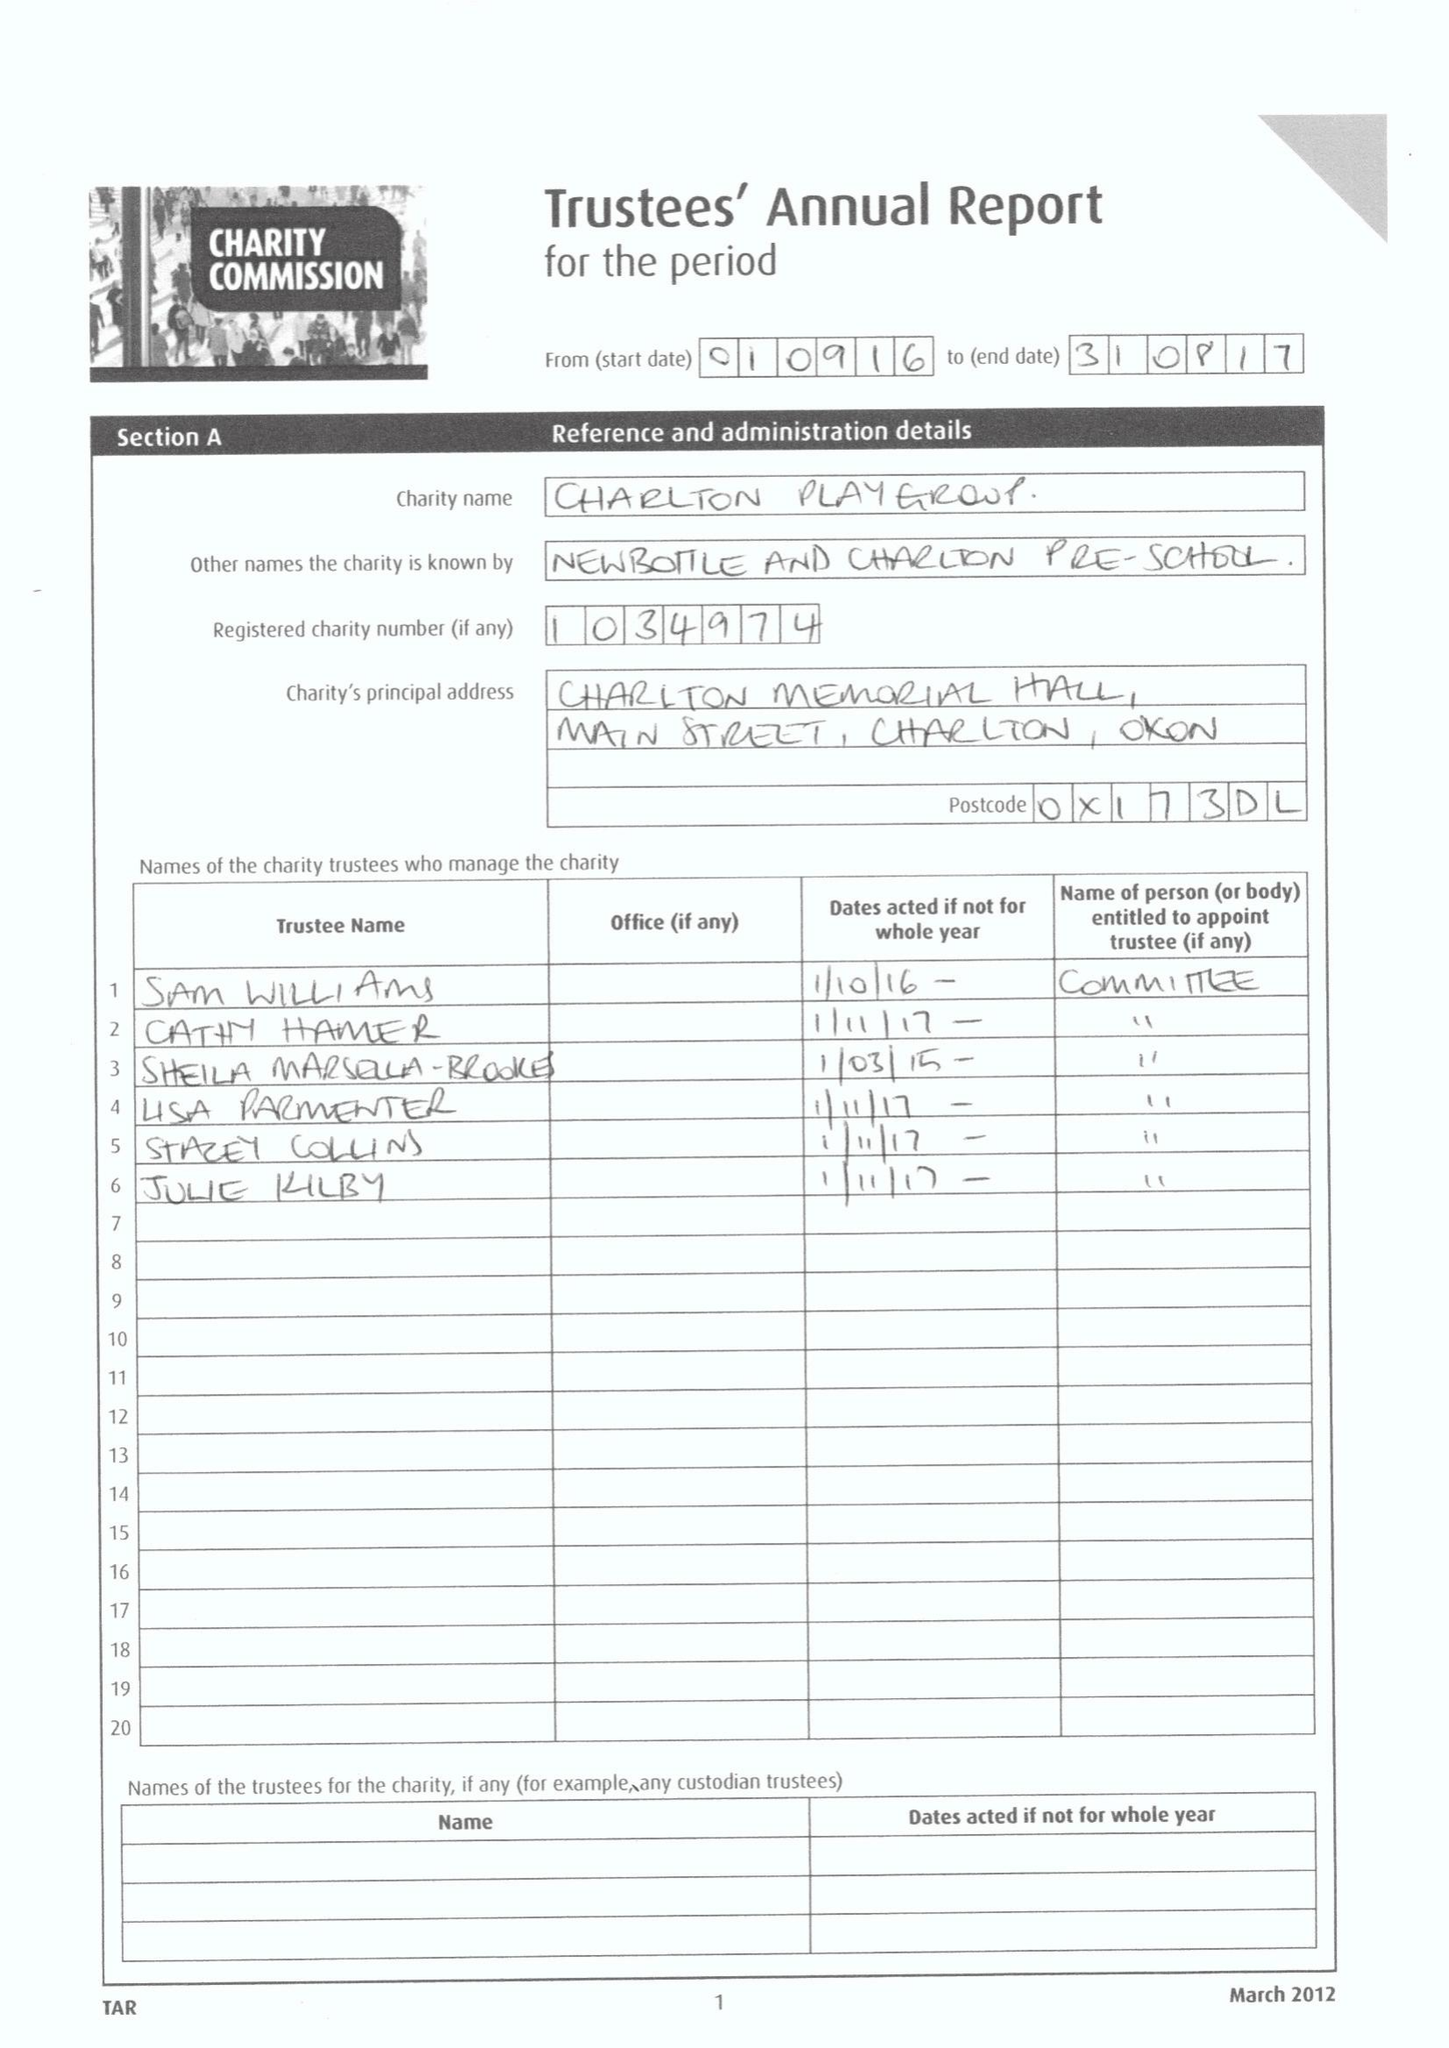What is the value for the address__postcode?
Answer the question using a single word or phrase. OX17 3DL 